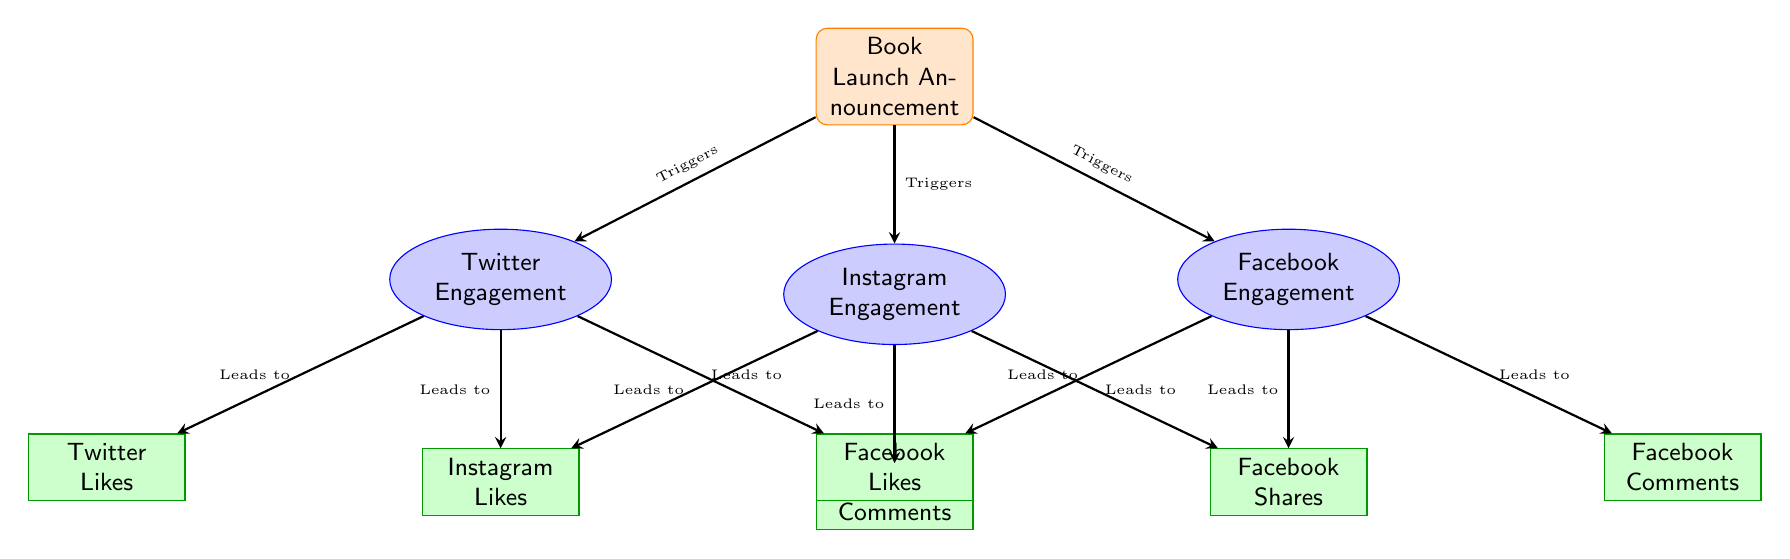What triggers Twitter engagement in the diagram? The diagram shows that the "Book Launch Announcement" triggers Twitter engagement, as indicated by the arrow pointing from the announcement to the Twitter engagement node.
Answer: Book Launch Announcement How many engagement metrics are shown for Instagram? There are three metrics listed under Instagram engagement: Instagram Likes, Instagram Comments, and Instagram Shares.
Answer: 3 What is the relationship between Facebook Engagement and Facebook Likes? The diagram indicates that Facebook Engagement leads to Facebook Likes, as shown by the arrow connecting the two nodes.
Answer: Leads to Which platform has the least number of metrics associated with it? Instagram has three engagement metrics, while Twitter has three and Facebook has three as well; all platforms have the same number of metrics. Therefore, no platform is least.
Answer: No platform is least What do all the engagement nodes lead to? Each engagement node (Twitter, Instagram, Facebook) leads to specific metrics representing user interactions, such as likes and comments.
Answer: Specific metrics What type of shape is used to represent the announcement in the diagram? The shape used to represent the announcement is a rectangle with rounded corners, as indicated in the formatting specifications in the diagram.
Answer: Rectangle with rounded corners How do Facebook Engagement and Instagram Engagement compare in terms of structure? Both Facebook and Instagram Engagement nodes are formatted the same way (as ellipses) and each leads to three specific metrics, showing identical structural representation in the diagram.
Answer: Identical structure What color indicates the engagement metrics in the diagram? The engagement metrics are represented in a green color (specifically, a green shade).
Answer: Green Which metric is related to Twitter but not to Facebook? Twitter Comments is a metric specifically associated with Twitter, as there is no equivalent metric under the Facebook engagement node.
Answer: Twitter Comments 